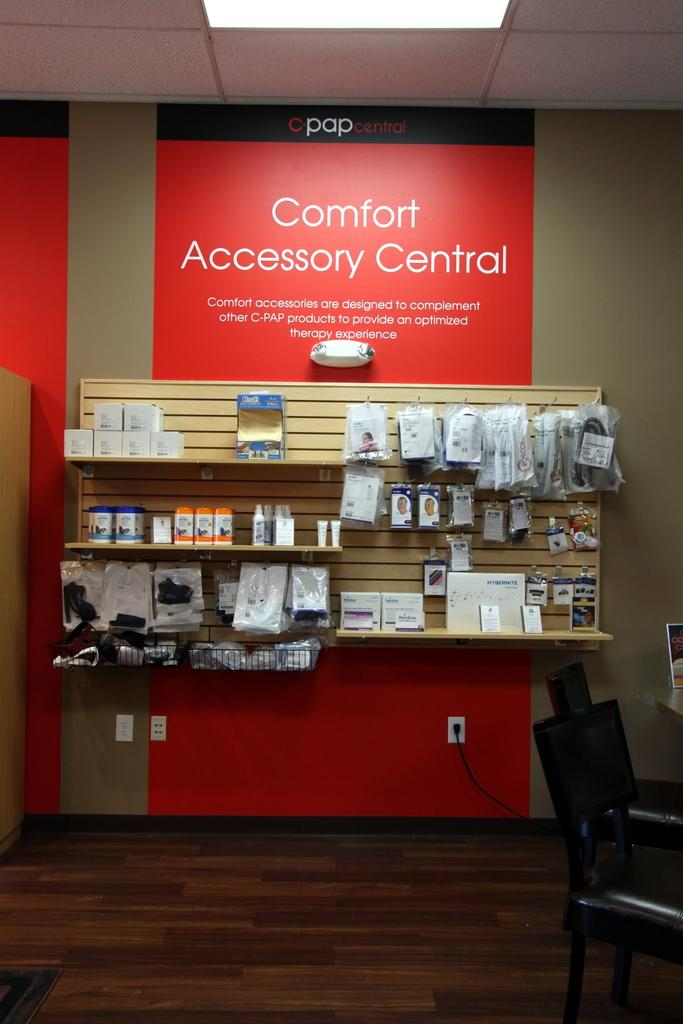<image>
Write a terse but informative summary of the picture. Large red sign in a store that says "Comfort Accessory Central". 